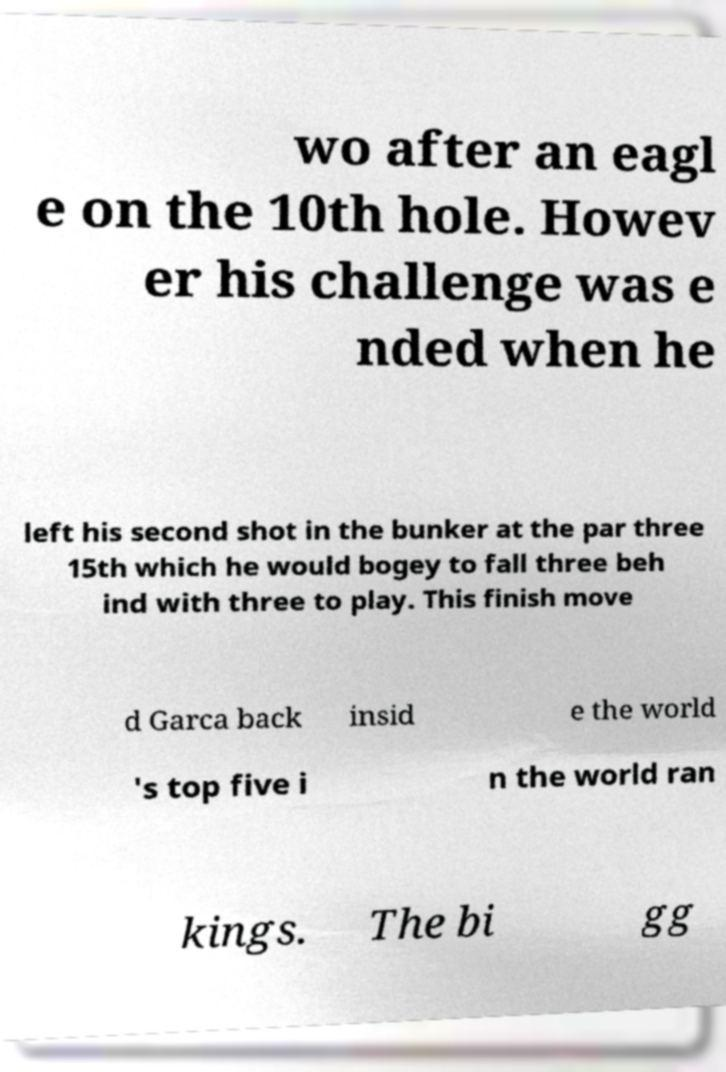I need the written content from this picture converted into text. Can you do that? wo after an eagl e on the 10th hole. Howev er his challenge was e nded when he left his second shot in the bunker at the par three 15th which he would bogey to fall three beh ind with three to play. This finish move d Garca back insid e the world 's top five i n the world ran kings. The bi gg 